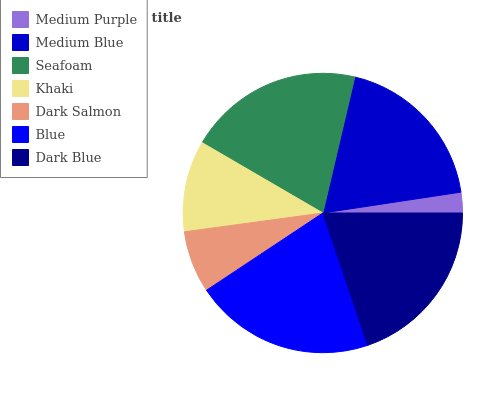Is Medium Purple the minimum?
Answer yes or no. Yes. Is Blue the maximum?
Answer yes or no. Yes. Is Medium Blue the minimum?
Answer yes or no. No. Is Medium Blue the maximum?
Answer yes or no. No. Is Medium Blue greater than Medium Purple?
Answer yes or no. Yes. Is Medium Purple less than Medium Blue?
Answer yes or no. Yes. Is Medium Purple greater than Medium Blue?
Answer yes or no. No. Is Medium Blue less than Medium Purple?
Answer yes or no. No. Is Medium Blue the high median?
Answer yes or no. Yes. Is Medium Blue the low median?
Answer yes or no. Yes. Is Dark Salmon the high median?
Answer yes or no. No. Is Dark Blue the low median?
Answer yes or no. No. 